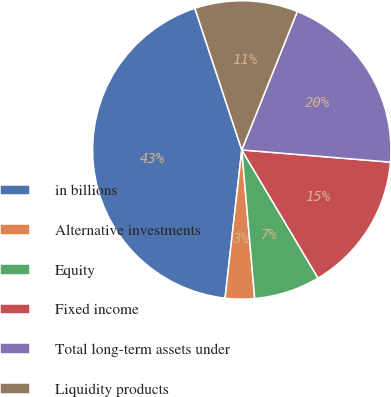<chart> <loc_0><loc_0><loc_500><loc_500><pie_chart><fcel>in billions<fcel>Alternative investments<fcel>Equity<fcel>Fixed income<fcel>Total long-term assets under<fcel>Liquidity products<nl><fcel>43.12%<fcel>3.17%<fcel>7.16%<fcel>15.15%<fcel>20.24%<fcel>11.16%<nl></chart> 